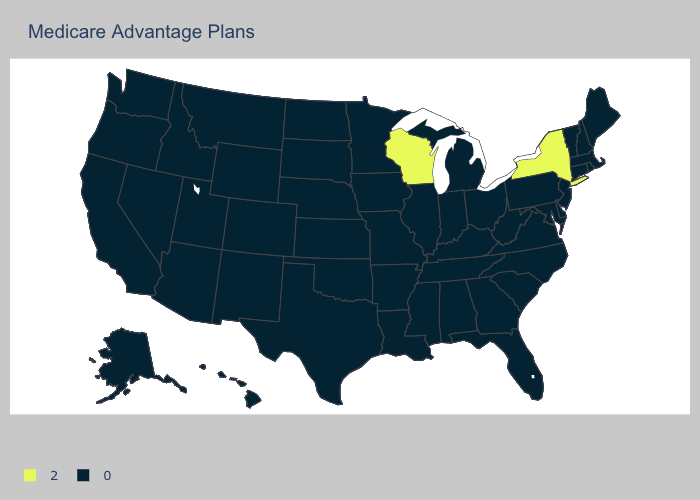Name the states that have a value in the range 2?
Write a very short answer. New York, Wisconsin. Which states have the lowest value in the USA?
Answer briefly. Alaska, Alabama, Arkansas, Arizona, California, Colorado, Connecticut, Delaware, Florida, Georgia, Hawaii, Iowa, Idaho, Illinois, Indiana, Kansas, Kentucky, Louisiana, Massachusetts, Maryland, Maine, Michigan, Minnesota, Missouri, Mississippi, Montana, North Carolina, North Dakota, Nebraska, New Hampshire, New Jersey, New Mexico, Nevada, Ohio, Oklahoma, Oregon, Pennsylvania, Rhode Island, South Carolina, South Dakota, Tennessee, Texas, Utah, Virginia, Vermont, Washington, West Virginia, Wyoming. What is the highest value in the USA?
Answer briefly. 2. What is the lowest value in the USA?
Keep it brief. 0. Which states have the lowest value in the South?
Quick response, please. Alabama, Arkansas, Delaware, Florida, Georgia, Kentucky, Louisiana, Maryland, Mississippi, North Carolina, Oklahoma, South Carolina, Tennessee, Texas, Virginia, West Virginia. What is the value of North Carolina?
Quick response, please. 0. Does Indiana have the same value as New York?
Write a very short answer. No. Does the map have missing data?
Answer briefly. No. Among the states that border Kentucky , which have the lowest value?
Keep it brief. Illinois, Indiana, Missouri, Ohio, Tennessee, Virginia, West Virginia. What is the highest value in states that border Virginia?
Concise answer only. 0. Name the states that have a value in the range 2?
Give a very brief answer. New York, Wisconsin. Name the states that have a value in the range 2?
Quick response, please. New York, Wisconsin. Does the first symbol in the legend represent the smallest category?
Be succinct. No. Name the states that have a value in the range 0?
Keep it brief. Alaska, Alabama, Arkansas, Arizona, California, Colorado, Connecticut, Delaware, Florida, Georgia, Hawaii, Iowa, Idaho, Illinois, Indiana, Kansas, Kentucky, Louisiana, Massachusetts, Maryland, Maine, Michigan, Minnesota, Missouri, Mississippi, Montana, North Carolina, North Dakota, Nebraska, New Hampshire, New Jersey, New Mexico, Nevada, Ohio, Oklahoma, Oregon, Pennsylvania, Rhode Island, South Carolina, South Dakota, Tennessee, Texas, Utah, Virginia, Vermont, Washington, West Virginia, Wyoming. Which states have the highest value in the USA?
Short answer required. New York, Wisconsin. 